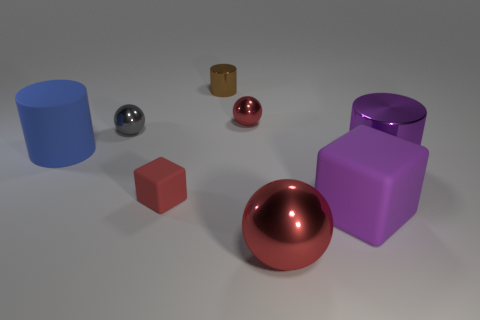Add 1 purple blocks. How many objects exist? 9 Subtract all blocks. How many objects are left? 6 Add 2 small brown shiny cylinders. How many small brown shiny cylinders are left? 3 Add 8 tiny metallic cylinders. How many tiny metallic cylinders exist? 9 Subtract 1 blue cylinders. How many objects are left? 7 Subtract all red rubber blocks. Subtract all small red metal things. How many objects are left? 6 